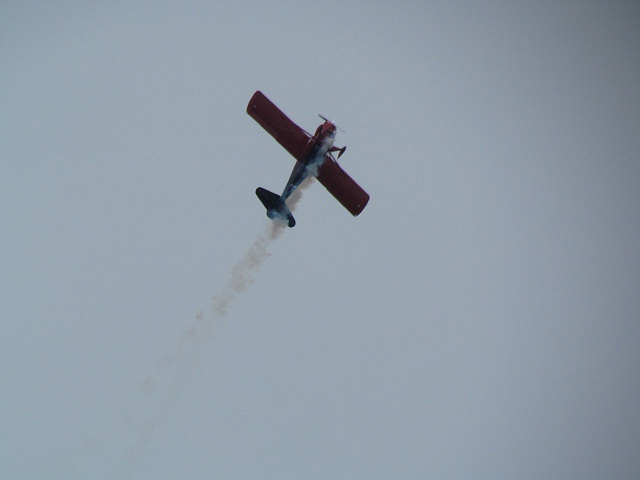Describe the objects in this image and their specific colors. I can see a airplane in darkgray, black, gray, and blue tones in this image. 